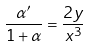<formula> <loc_0><loc_0><loc_500><loc_500>\frac { \alpha ^ { \prime } } { 1 + \alpha } = \frac { 2 y } { x ^ { 3 } }</formula> 